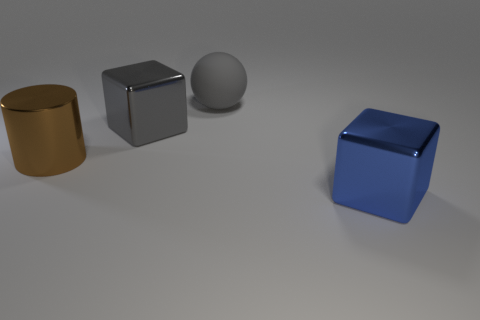Is there another cylinder of the same color as the big cylinder?
Offer a terse response. No. There is a metallic cylinder that is the same size as the matte sphere; what color is it?
Keep it short and to the point. Brown. There is a large matte object; does it have the same color as the cube that is behind the big brown shiny object?
Make the answer very short. Yes. The rubber thing is what color?
Your response must be concise. Gray. There is a cube to the left of the large rubber ball; what is its material?
Provide a succinct answer. Metal. What size is the blue metallic thing that is the same shape as the large gray metallic thing?
Your response must be concise. Large. Are there fewer big brown metallic cylinders that are to the right of the large blue metallic block than big blue cubes?
Offer a terse response. Yes. Are there any large brown metal objects?
Provide a short and direct response. Yes. What color is the other large thing that is the same shape as the gray shiny object?
Provide a short and direct response. Blue. Do the large object that is in front of the big metallic cylinder and the metal cylinder have the same color?
Keep it short and to the point. No. 